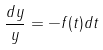Convert formula to latex. <formula><loc_0><loc_0><loc_500><loc_500>\frac { d y } { y } = - f ( t ) d t</formula> 